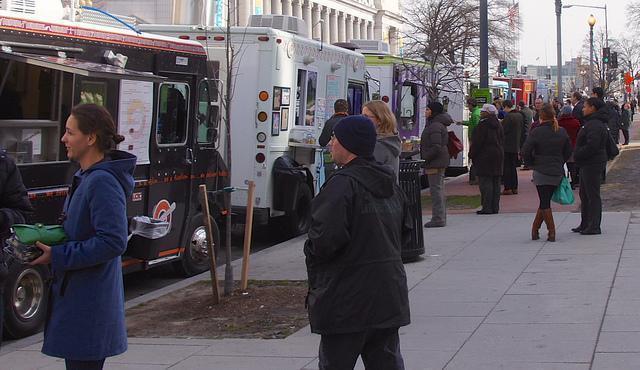What is the color of second vehicle?
Indicate the correct response and explain using: 'Answer: answer
Rationale: rationale.'
Options: Brown, pink, red, white. Answer: white.
Rationale: The second vehicle is not pink, red, or brown. 